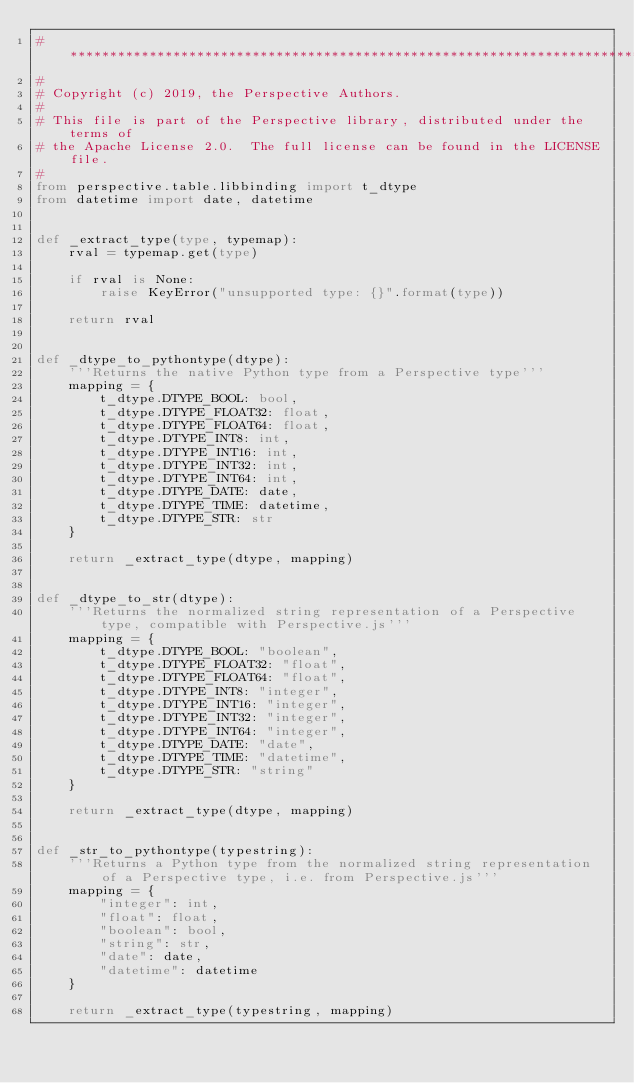Convert code to text. <code><loc_0><loc_0><loc_500><loc_500><_Python_># *****************************************************************************
#
# Copyright (c) 2019, the Perspective Authors.
#
# This file is part of the Perspective library, distributed under the terms of
# the Apache License 2.0.  The full license can be found in the LICENSE file.
#
from perspective.table.libbinding import t_dtype
from datetime import date, datetime


def _extract_type(type, typemap):
    rval = typemap.get(type)

    if rval is None:
        raise KeyError("unsupported type: {}".format(type))

    return rval


def _dtype_to_pythontype(dtype):
    '''Returns the native Python type from a Perspective type'''
    mapping = {
        t_dtype.DTYPE_BOOL: bool,
        t_dtype.DTYPE_FLOAT32: float,
        t_dtype.DTYPE_FLOAT64: float,
        t_dtype.DTYPE_INT8: int,
        t_dtype.DTYPE_INT16: int,
        t_dtype.DTYPE_INT32: int,
        t_dtype.DTYPE_INT64: int,
        t_dtype.DTYPE_DATE: date,
        t_dtype.DTYPE_TIME: datetime,
        t_dtype.DTYPE_STR: str
    }

    return _extract_type(dtype, mapping)


def _dtype_to_str(dtype):
    '''Returns the normalized string representation of a Perspective type, compatible with Perspective.js'''
    mapping = {
        t_dtype.DTYPE_BOOL: "boolean",
        t_dtype.DTYPE_FLOAT32: "float",
        t_dtype.DTYPE_FLOAT64: "float",
        t_dtype.DTYPE_INT8: "integer",
        t_dtype.DTYPE_INT16: "integer",
        t_dtype.DTYPE_INT32: "integer",
        t_dtype.DTYPE_INT64: "integer",
        t_dtype.DTYPE_DATE: "date",
        t_dtype.DTYPE_TIME: "datetime",
        t_dtype.DTYPE_STR: "string"
    }

    return _extract_type(dtype, mapping)


def _str_to_pythontype(typestring):
    '''Returns a Python type from the normalized string representation of a Perspective type, i.e. from Perspective.js'''
    mapping = {
        "integer": int,
        "float": float,
        "boolean": bool,
        "string": str,
        "date": date,
        "datetime": datetime
    }

    return _extract_type(typestring, mapping)
</code> 